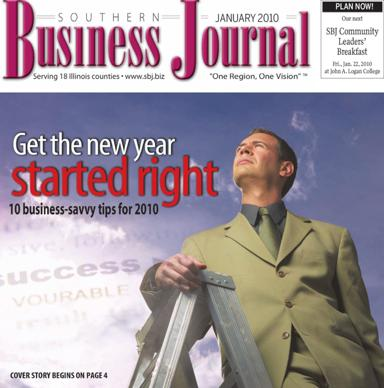Who is the person featured on the cover of the journal, and what might his significance be? The man on the cover appears to be a professional poised to ascend a corporate ladder, symbolizing ambition and the climb towards success in the new year. His presence emphasizes the theme of leadership and goal achievement that aligns with the contents of the magazine, particularly the business savvy tips for 2010. 